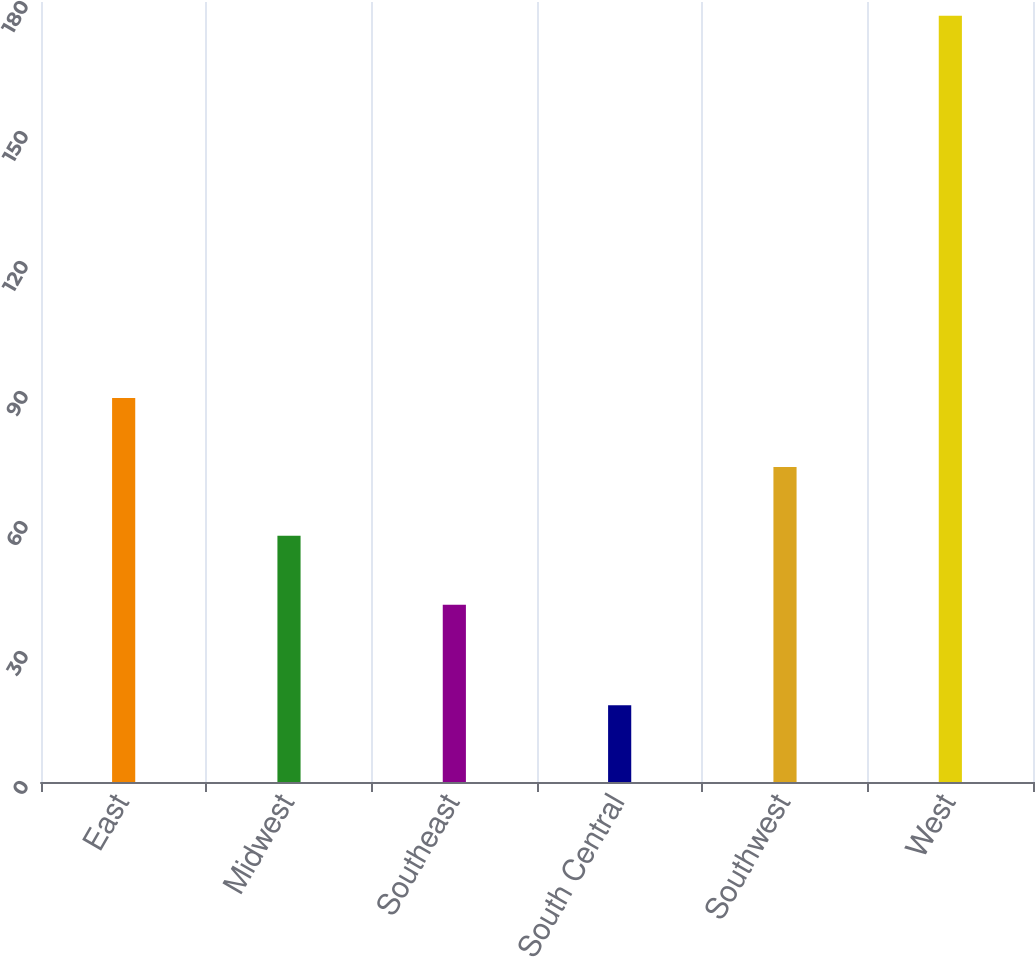<chart> <loc_0><loc_0><loc_500><loc_500><bar_chart><fcel>East<fcel>Midwest<fcel>Southeast<fcel>South Central<fcel>Southwest<fcel>West<nl><fcel>88.63<fcel>56.81<fcel>40.9<fcel>17.7<fcel>72.72<fcel>176.8<nl></chart> 